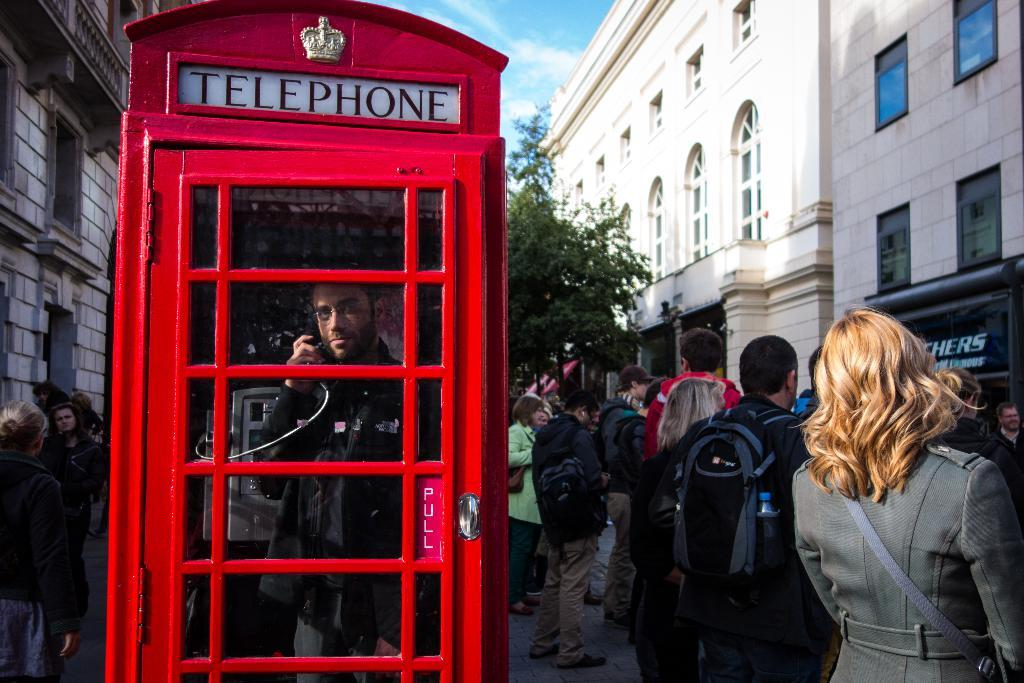<image>
Share a concise interpretation of the image provided. a crowd of people surround a red telephone box with a man inside on the phone 